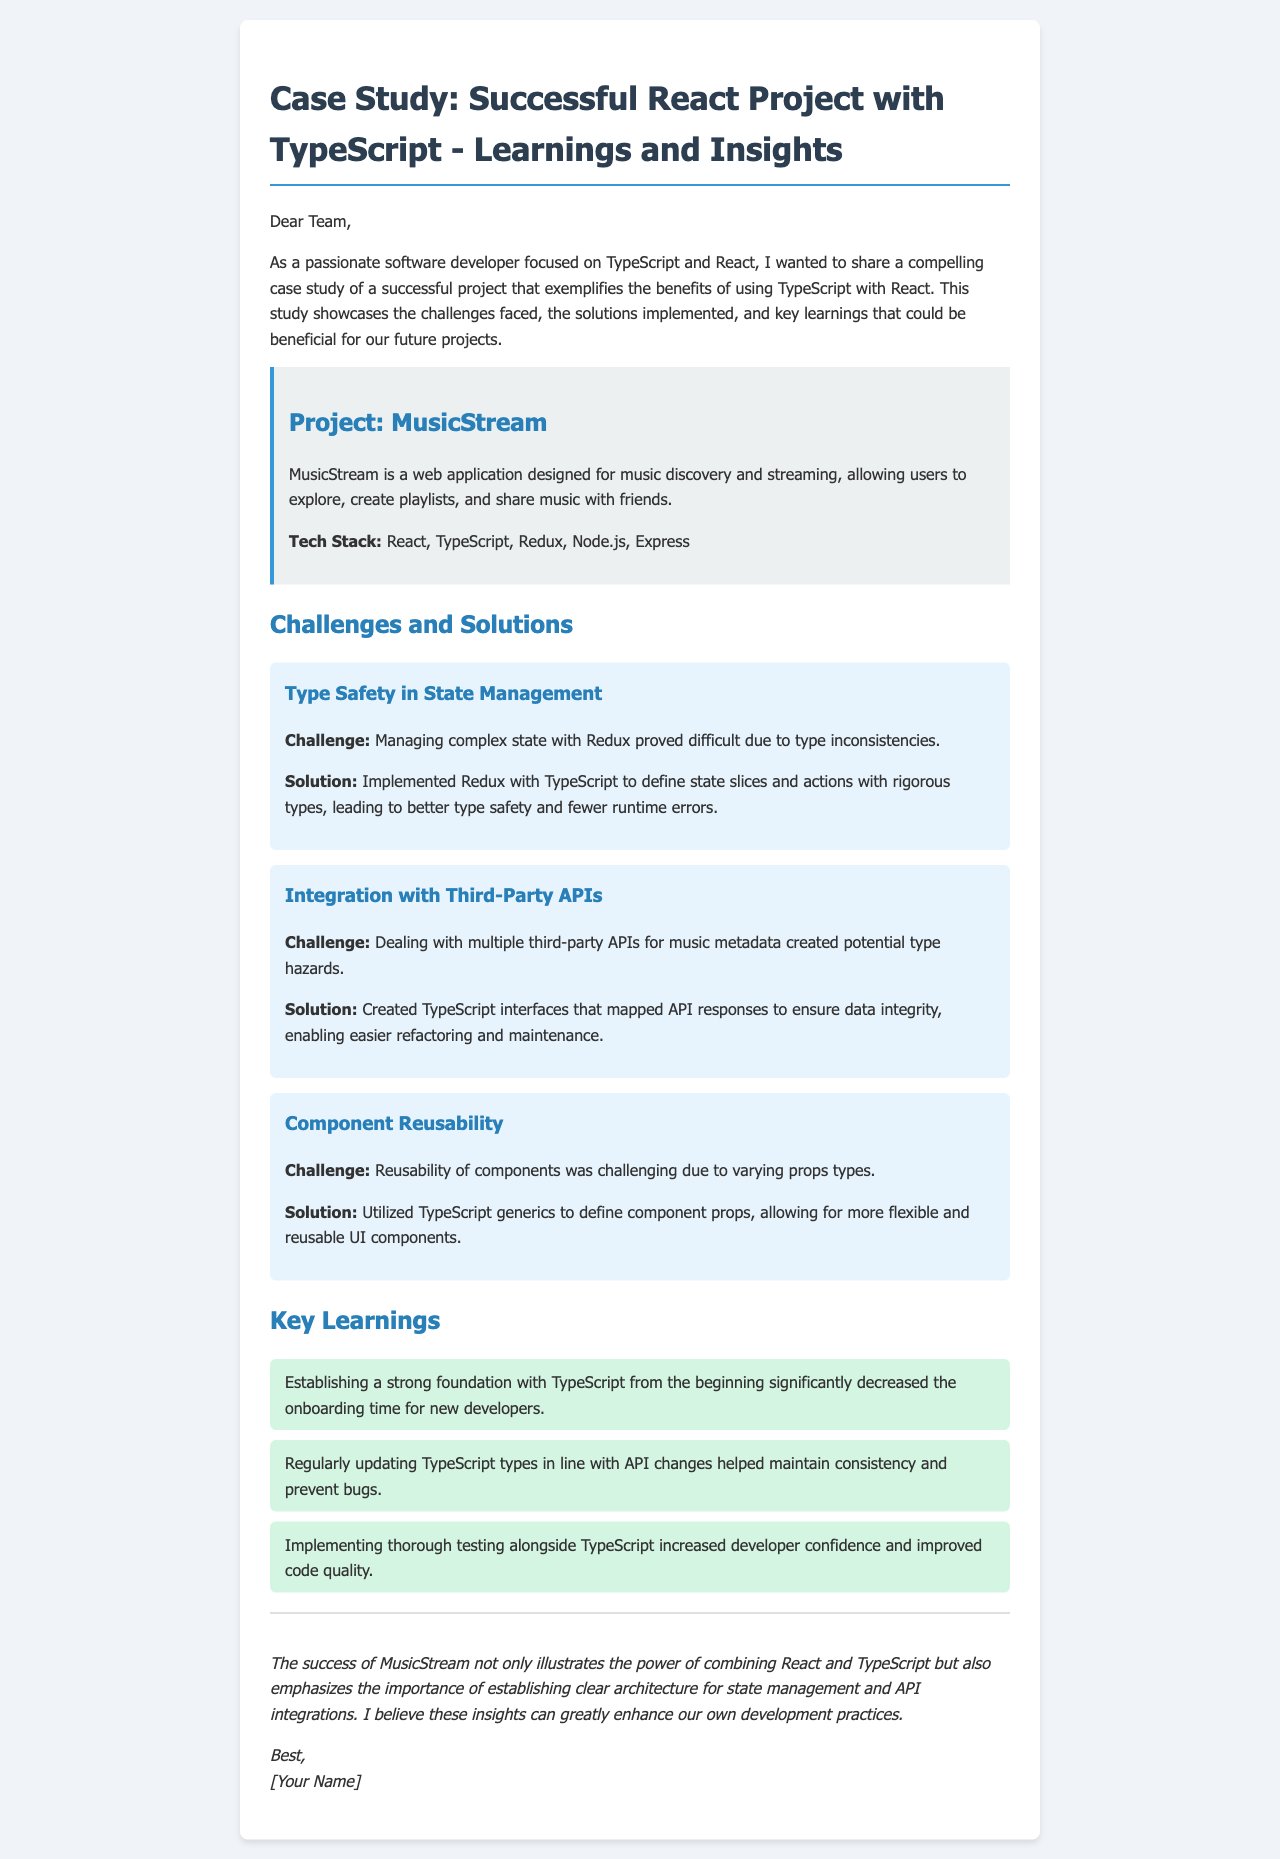What is the project name? The project name is mentioned in the project information section of the document.
Answer: MusicStream What is the primary purpose of MusicStream? The purpose of MusicStream is defined in the project description.
Answer: Music discovery and streaming What technology is used for state management? The technology used for state management is specified in the tech stack.
Answer: Redux What challenge was encountered regarding third-party APIs? The challenge related to third-party APIs is described under challenges and solutions.
Answer: Type hazards What was utilized to improve component reusability? The solution for improving component reusability is outlined in the relevant challenge section.
Answer: TypeScript generics How many key learnings are mentioned? The number of key learnings can be counted from the list provided in the document.
Answer: Three What was a significant benefit of using TypeScript from the beginning? The benefit of establishing TypeScript early on is stated in the key learnings.
Answer: Decreased onboarding time What is the concluding sentiment of the email? The conclusion indicates the overall sentiment about the project's success and insights gained.
Answer: Positive 